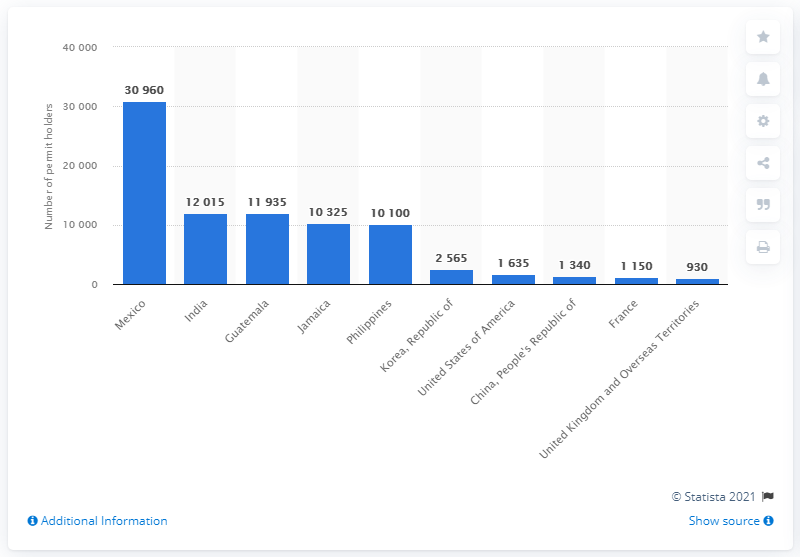Give some essential details in this illustration. In 2019, the largest country of origin of TFWP permit holders was Mexico. 